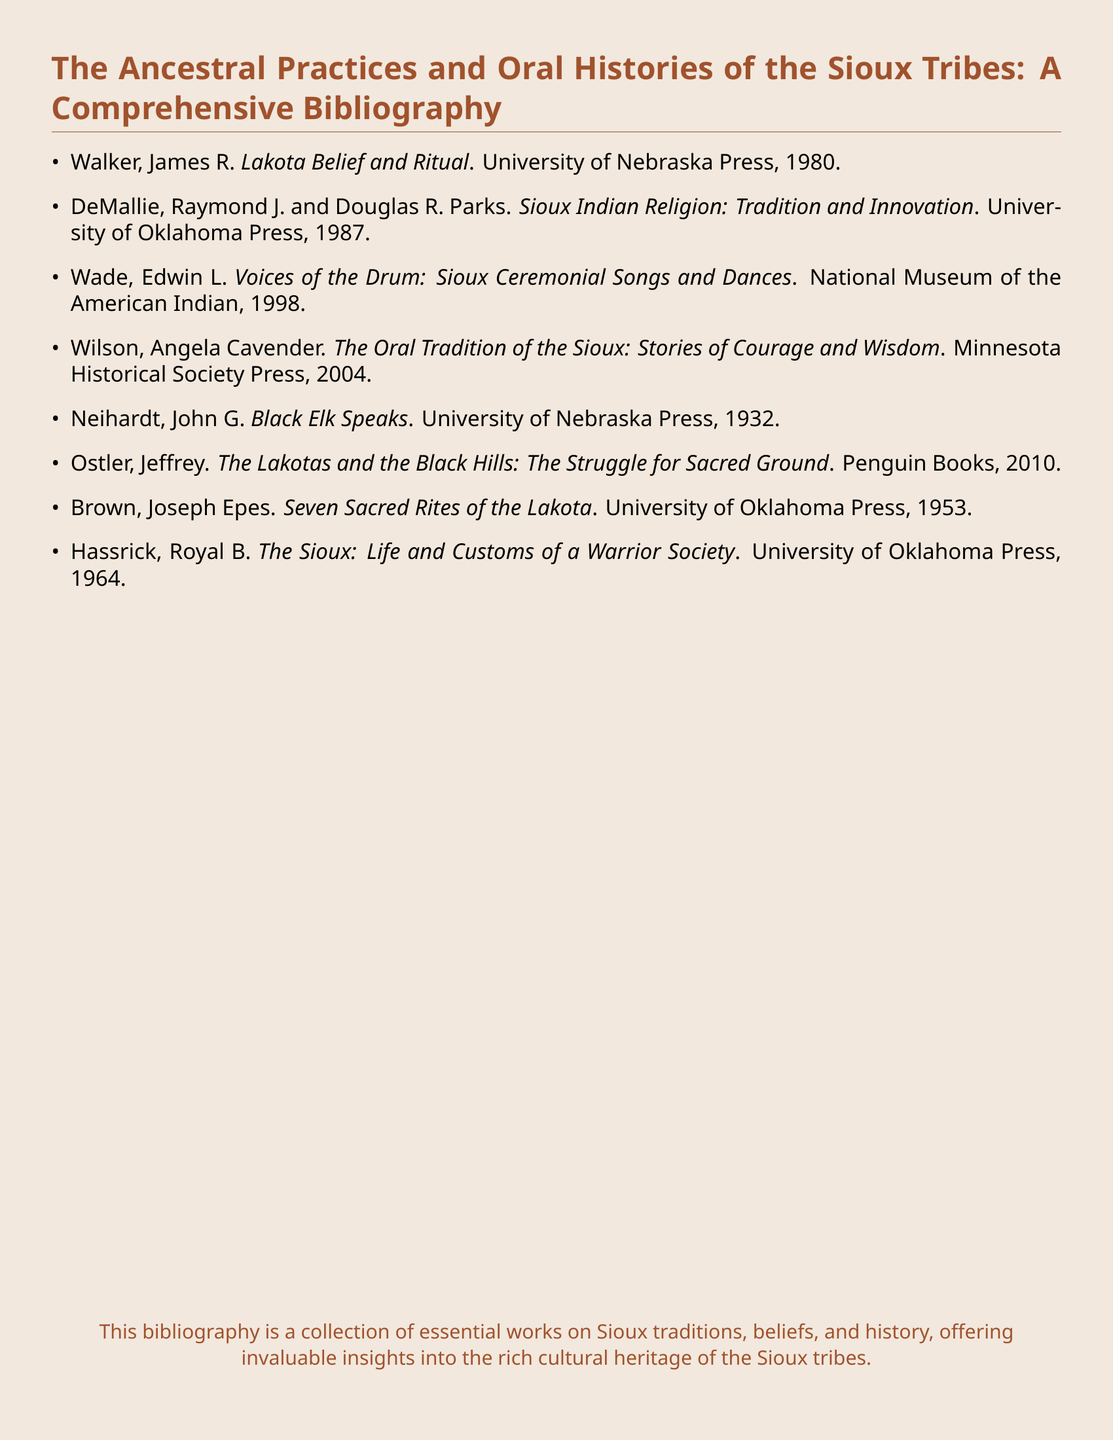What is the title of the bibliography? The title is indicated at the top of the document, summarizing the content regarding Sioux tribal practices and histories.
Answer: The Ancestral Practices and Oral Histories of the Sioux Tribes: A Comprehensive Bibliography Who authored "Lakota Belief and Ritual"? The authorship of the work is mentioned in the document, providing a clear connection to the study of Lakota traditions.
Answer: James R. Walker In what year was "Black Elk Speaks" published? The publication year for this specific title is clearly stated beside the title in the bibliography.
Answer: 1932 What is the focus of the book by Edwin L. Wade? The title reflects the subject matter concerning the ceremonial aspects of Sioux culture, indicating its thematic direction.
Answer: Sioux Ceremonial Songs and Dances Which publisher released "Seven Sacred Rites of the Lakota"? The publisher's name is listed next to the title and author, which helps in identifying the source of the work.
Answer: University of Oklahoma Press What common theme is addressed in several works listed? The document highlights the connection between different titles reflecting on significant Sioux cultural elements, indicating an overarching theme.
Answer: Sioux traditions How many titles are included in the bibliography? The total number of titles is represented by counting the list provided in the document.
Answer: 8 